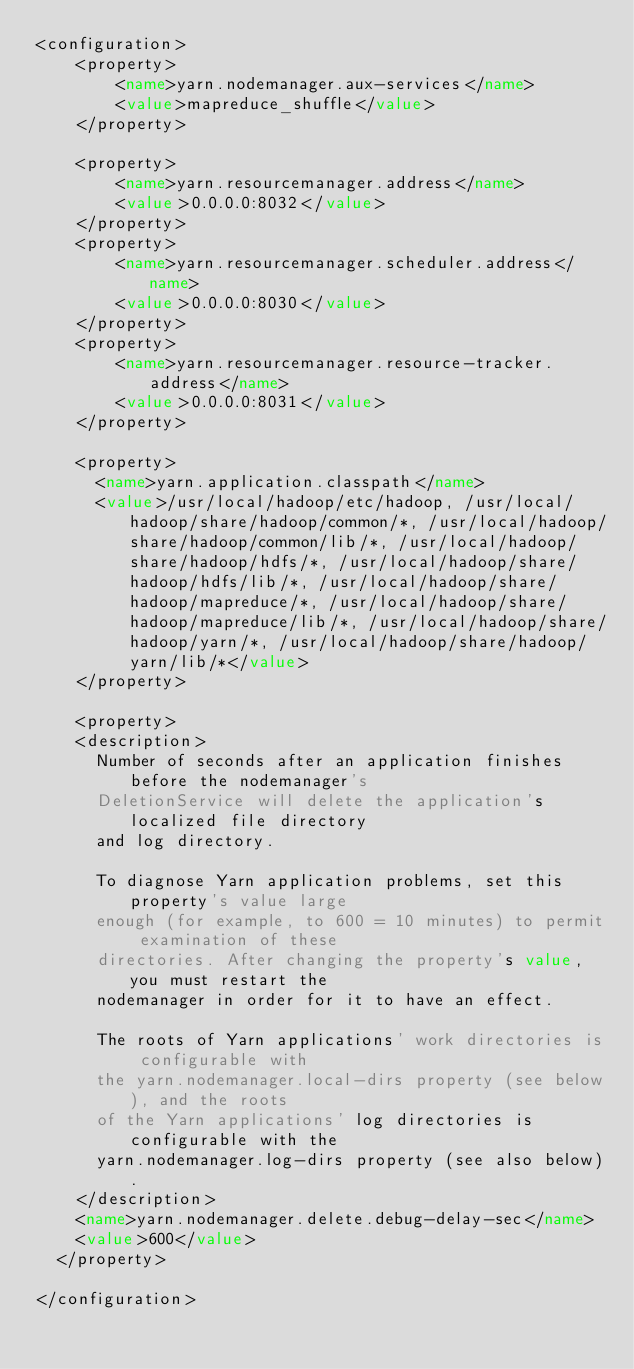<code> <loc_0><loc_0><loc_500><loc_500><_XML_><configuration>
    <property>
        <name>yarn.nodemanager.aux-services</name>
        <value>mapreduce_shuffle</value>
    </property>

    <property>
        <name>yarn.resourcemanager.address</name>
        <value>0.0.0.0:8032</value>
    </property>
    <property>
        <name>yarn.resourcemanager.scheduler.address</name>
        <value>0.0.0.0:8030</value>
    </property>
    <property>
        <name>yarn.resourcemanager.resource-tracker.address</name>
        <value>0.0.0.0:8031</value>
    </property>

    <property>
      <name>yarn.application.classpath</name>
      <value>/usr/local/hadoop/etc/hadoop, /usr/local/hadoop/share/hadoop/common/*, /usr/local/hadoop/share/hadoop/common/lib/*, /usr/local/hadoop/share/hadoop/hdfs/*, /usr/local/hadoop/share/hadoop/hdfs/lib/*, /usr/local/hadoop/share/hadoop/mapreduce/*, /usr/local/hadoop/share/hadoop/mapreduce/lib/*, /usr/local/hadoop/share/hadoop/yarn/*, /usr/local/hadoop/share/hadoop/yarn/lib/*</value>
    </property>

    <property>
    <description>
      Number of seconds after an application finishes before the nodemanager's
      DeletionService will delete the application's localized file directory
      and log directory.

      To diagnose Yarn application problems, set this property's value large
      enough (for example, to 600 = 10 minutes) to permit examination of these
      directories. After changing the property's value, you must restart the
      nodemanager in order for it to have an effect.

      The roots of Yarn applications' work directories is configurable with
      the yarn.nodemanager.local-dirs property (see below), and the roots
      of the Yarn applications' log directories is configurable with the
      yarn.nodemanager.log-dirs property (see also below).
    </description>
    <name>yarn.nodemanager.delete.debug-delay-sec</name>
    <value>600</value>
  </property>

</configuration>
</code> 